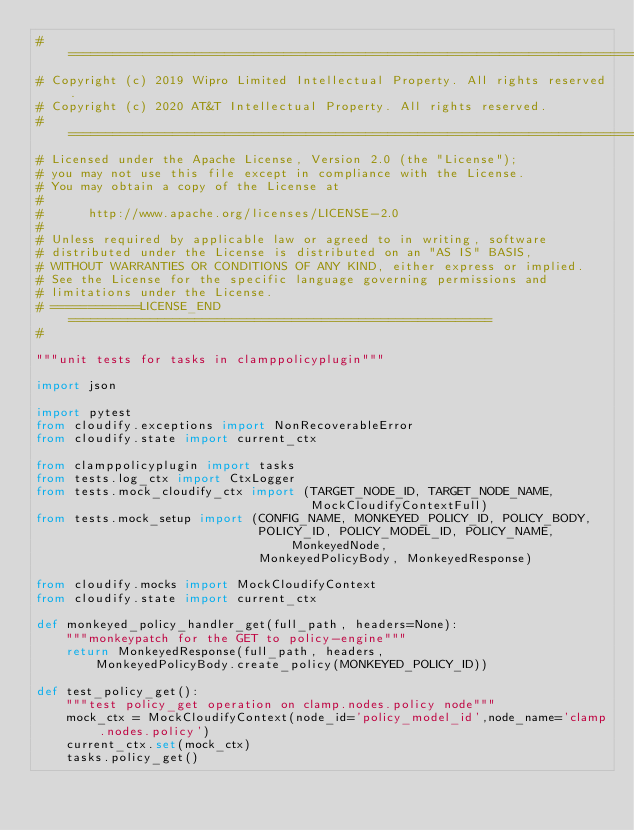<code> <loc_0><loc_0><loc_500><loc_500><_Python_># ================================================================================
# Copyright (c) 2019 Wipro Limited Intellectual Property. All rights reserved.
# Copyright (c) 2020 AT&T Intellectual Property. All rights reserved.
# ================================================================================
# Licensed under the Apache License, Version 2.0 (the "License");
# you may not use this file except in compliance with the License.
# You may obtain a copy of the License at
#
#      http://www.apache.org/licenses/LICENSE-2.0
#
# Unless required by applicable law or agreed to in writing, software
# distributed under the License is distributed on an "AS IS" BASIS,
# WITHOUT WARRANTIES OR CONDITIONS OF ANY KIND, either express or implied.
# See the License for the specific language governing permissions and
# limitations under the License.
# ============LICENSE_END=========================================================
#

"""unit tests for tasks in clamppolicyplugin"""

import json

import pytest
from cloudify.exceptions import NonRecoverableError
from cloudify.state import current_ctx

from clamppolicyplugin import tasks
from tests.log_ctx import CtxLogger
from tests.mock_cloudify_ctx import (TARGET_NODE_ID, TARGET_NODE_NAME,
                                     MockCloudifyContextFull)
from tests.mock_setup import (CONFIG_NAME, MONKEYED_POLICY_ID, POLICY_BODY,
                              POLICY_ID, POLICY_MODEL_ID, POLICY_NAME, MonkeyedNode,
                              MonkeyedPolicyBody, MonkeyedResponse)

from cloudify.mocks import MockCloudifyContext
from cloudify.state import current_ctx

def monkeyed_policy_handler_get(full_path, headers=None):
    """monkeypatch for the GET to policy-engine"""
    return MonkeyedResponse(full_path, headers,
        MonkeyedPolicyBody.create_policy(MONKEYED_POLICY_ID))

def test_policy_get():
    """test policy_get operation on clamp.nodes.policy node"""
    mock_ctx = MockCloudifyContext(node_id='policy_model_id',node_name='clamp.nodes.policy')
    current_ctx.set(mock_ctx)
    tasks.policy_get()
</code> 